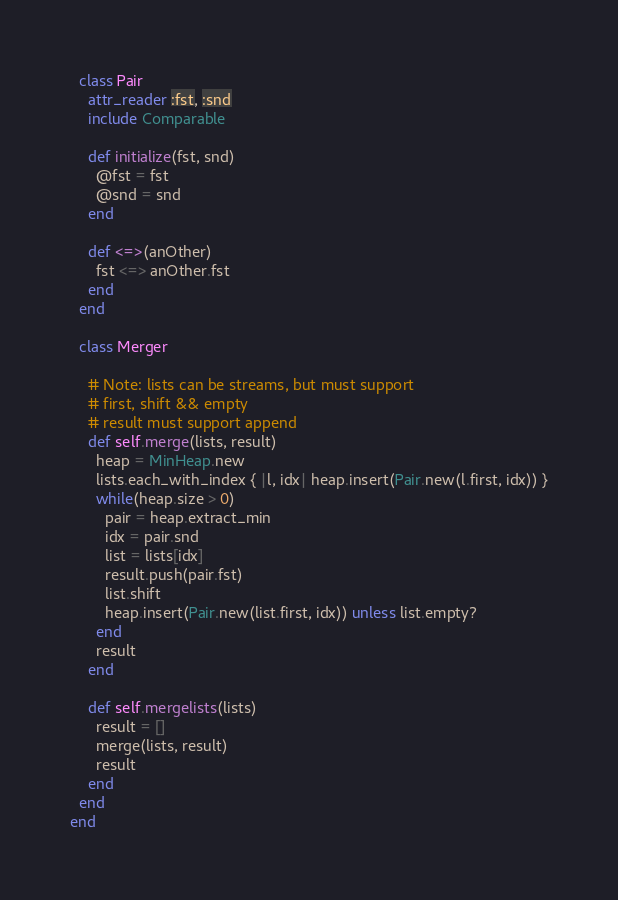Convert code to text. <code><loc_0><loc_0><loc_500><loc_500><_Ruby_>  class Pair
    attr_reader :fst, :snd
    include Comparable

    def initialize(fst, snd)
      @fst = fst
      @snd = snd
    end

    def <=>(anOther)
      fst <=> anOther.fst
    end
  end

  class Merger

    # Note: lists can be streams, but must support
    # first, shift && empty
    # result must support append
    def self.merge(lists, result)
      heap = MinHeap.new
      lists.each_with_index { |l, idx| heap.insert(Pair.new(l.first, idx)) }
      while(heap.size > 0)
        pair = heap.extract_min
        idx = pair.snd
        list = lists[idx]
        result.push(pair.fst)
        list.shift
        heap.insert(Pair.new(list.first, idx)) unless list.empty?
      end
      result
    end

    def self.mergelists(lists)
      result = []
      merge(lists, result)
      result
    end
  end
end
</code> 